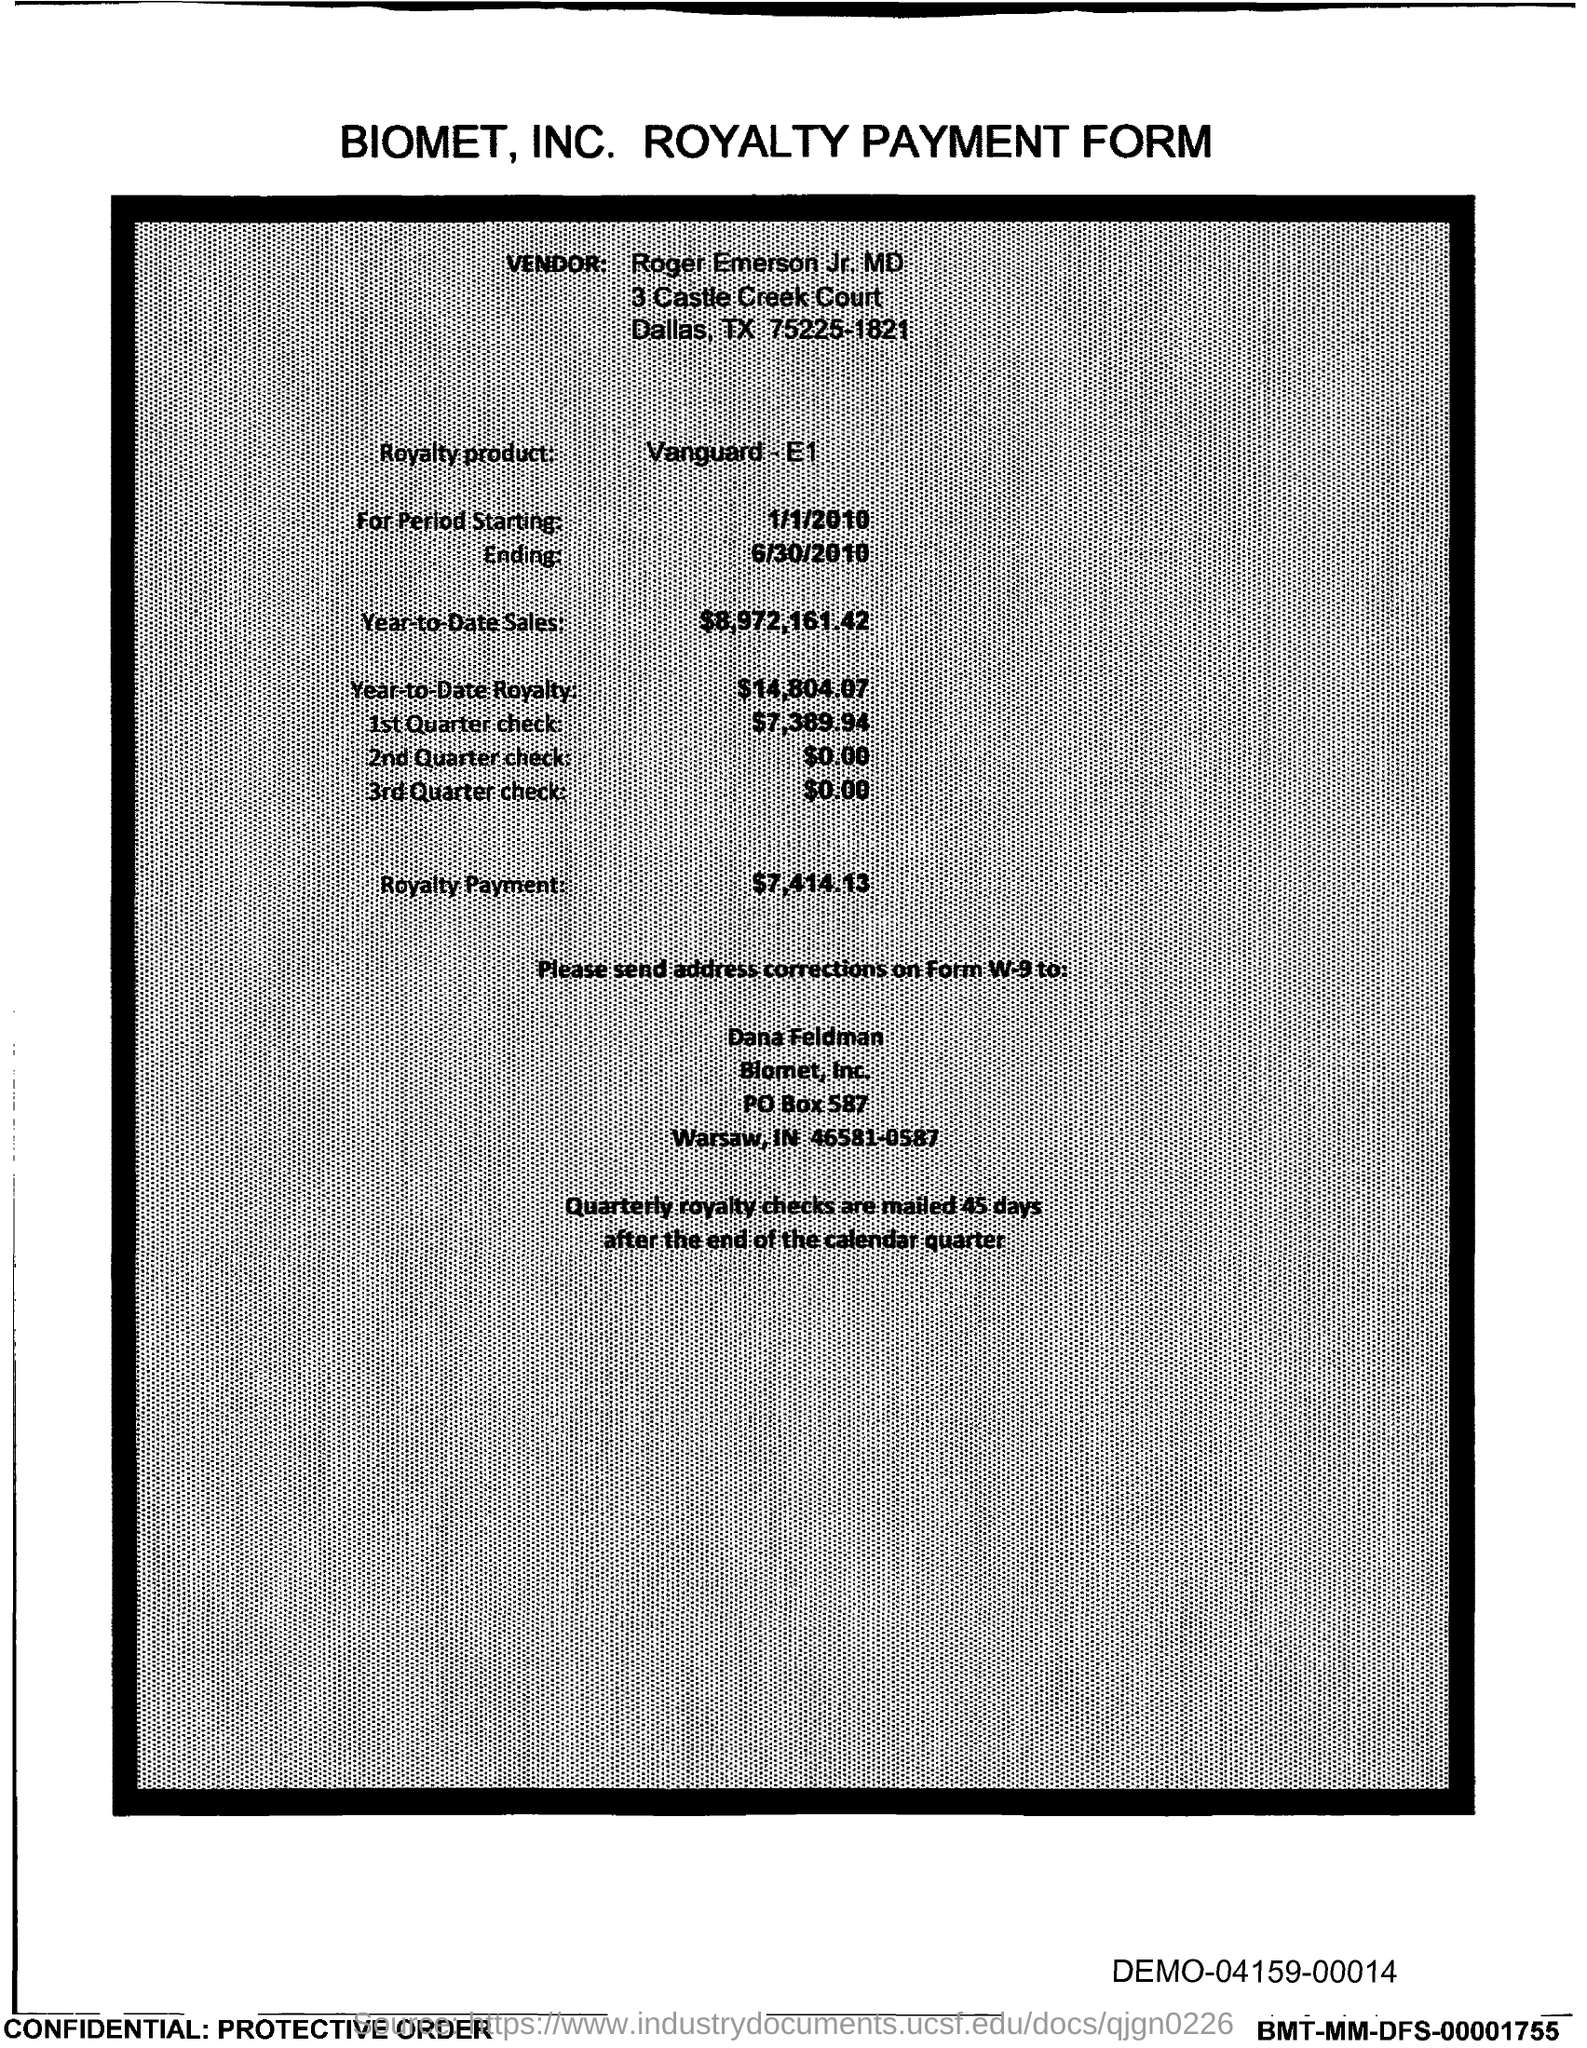What is the PO Box Number mentioned in the document?
Your answer should be very brief. 587. 